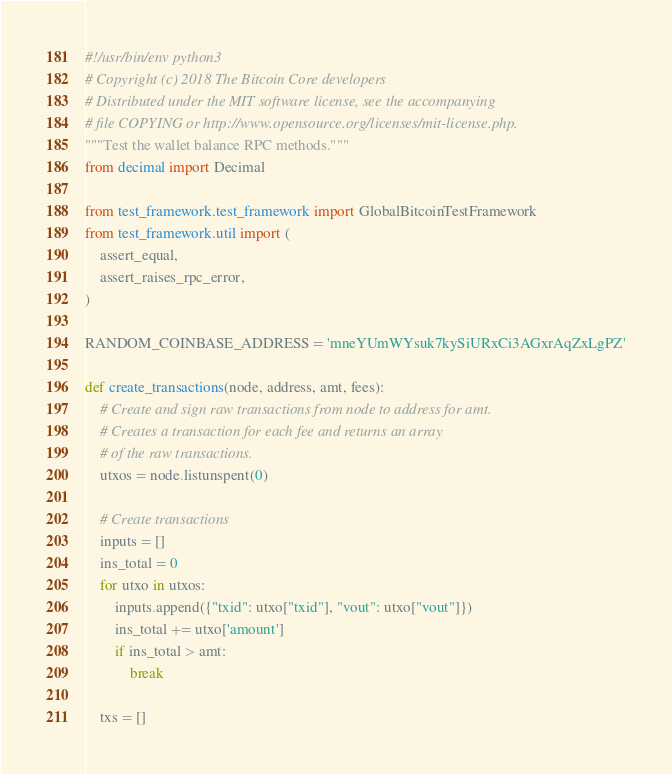<code> <loc_0><loc_0><loc_500><loc_500><_Python_>#!/usr/bin/env python3
# Copyright (c) 2018 The Bitcoin Core developers
# Distributed under the MIT software license, see the accompanying
# file COPYING or http://www.opensource.org/licenses/mit-license.php.
"""Test the wallet balance RPC methods."""
from decimal import Decimal

from test_framework.test_framework import GlobalBitcoinTestFramework
from test_framework.util import (
    assert_equal,
    assert_raises_rpc_error,
)

RANDOM_COINBASE_ADDRESS = 'mneYUmWYsuk7kySiURxCi3AGxrAqZxLgPZ'

def create_transactions(node, address, amt, fees):
    # Create and sign raw transactions from node to address for amt.
    # Creates a transaction for each fee and returns an array
    # of the raw transactions.
    utxos = node.listunspent(0)

    # Create transactions
    inputs = []
    ins_total = 0
    for utxo in utxos:
        inputs.append({"txid": utxo["txid"], "vout": utxo["vout"]})
        ins_total += utxo['amount']
        if ins_total > amt:
            break

    txs = []</code> 